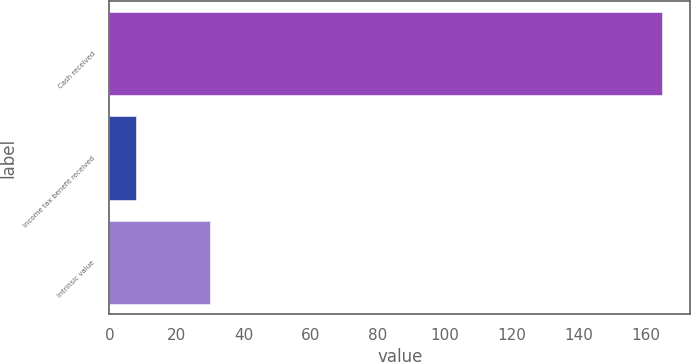Convert chart to OTSL. <chart><loc_0><loc_0><loc_500><loc_500><bar_chart><fcel>Cash received<fcel>Income tax benefit received<fcel>Intrinsic value<nl><fcel>165<fcel>8<fcel>30<nl></chart> 